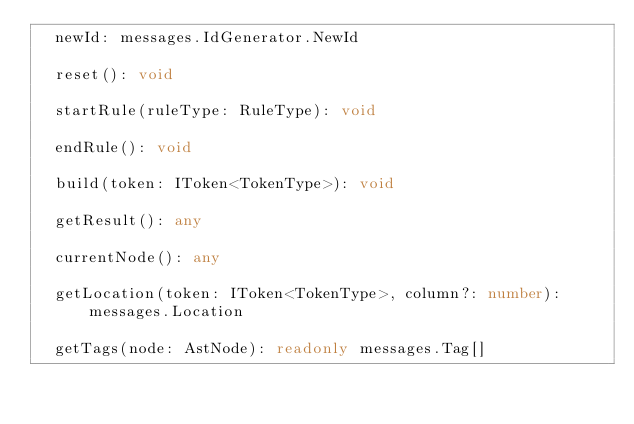Convert code to text. <code><loc_0><loc_0><loc_500><loc_500><_TypeScript_>  newId: messages.IdGenerator.NewId

  reset(): void

  startRule(ruleType: RuleType): void

  endRule(): void

  build(token: IToken<TokenType>): void

  getResult(): any

  currentNode(): any

  getLocation(token: IToken<TokenType>, column?: number): messages.Location

  getTags(node: AstNode): readonly messages.Tag[]
</code> 